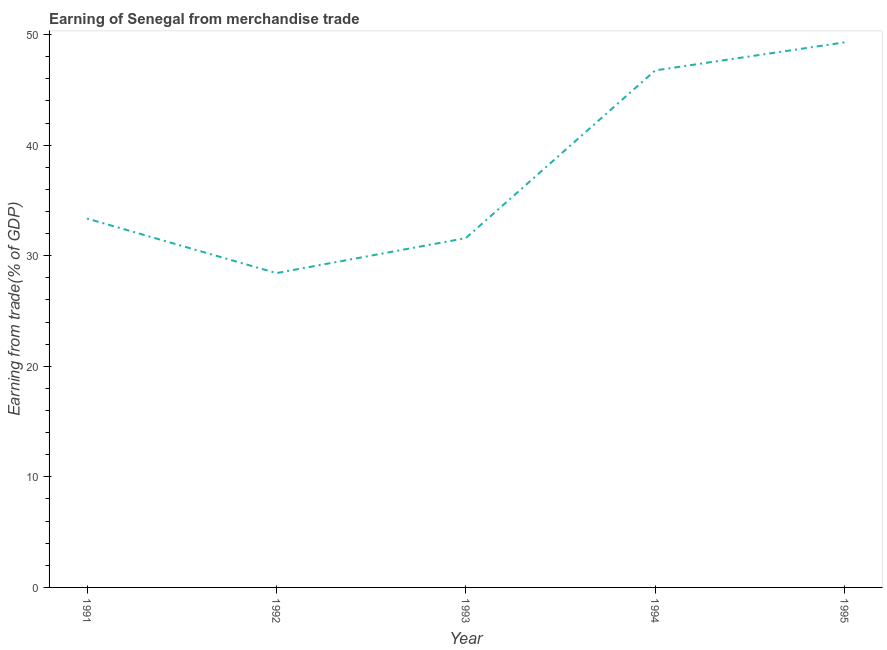What is the earning from merchandise trade in 1992?
Make the answer very short. 28.43. Across all years, what is the maximum earning from merchandise trade?
Your answer should be compact. 49.3. Across all years, what is the minimum earning from merchandise trade?
Make the answer very short. 28.43. What is the sum of the earning from merchandise trade?
Ensure brevity in your answer.  189.44. What is the difference between the earning from merchandise trade in 1991 and 1995?
Give a very brief answer. -15.93. What is the average earning from merchandise trade per year?
Keep it short and to the point. 37.89. What is the median earning from merchandise trade?
Offer a terse response. 33.36. Do a majority of the years between 1994 and 1991 (inclusive) have earning from merchandise trade greater than 12 %?
Give a very brief answer. Yes. What is the ratio of the earning from merchandise trade in 1994 to that in 1995?
Ensure brevity in your answer.  0.95. What is the difference between the highest and the second highest earning from merchandise trade?
Your response must be concise. 2.54. What is the difference between the highest and the lowest earning from merchandise trade?
Make the answer very short. 20.87. In how many years, is the earning from merchandise trade greater than the average earning from merchandise trade taken over all years?
Make the answer very short. 2. Does the earning from merchandise trade monotonically increase over the years?
Ensure brevity in your answer.  No. What is the title of the graph?
Provide a succinct answer. Earning of Senegal from merchandise trade. What is the label or title of the X-axis?
Ensure brevity in your answer.  Year. What is the label or title of the Y-axis?
Offer a very short reply. Earning from trade(% of GDP). What is the Earning from trade(% of GDP) of 1991?
Provide a short and direct response. 33.36. What is the Earning from trade(% of GDP) of 1992?
Give a very brief answer. 28.43. What is the Earning from trade(% of GDP) of 1993?
Make the answer very short. 31.59. What is the Earning from trade(% of GDP) of 1994?
Offer a very short reply. 46.76. What is the Earning from trade(% of GDP) in 1995?
Keep it short and to the point. 49.3. What is the difference between the Earning from trade(% of GDP) in 1991 and 1992?
Provide a short and direct response. 4.93. What is the difference between the Earning from trade(% of GDP) in 1991 and 1993?
Make the answer very short. 1.77. What is the difference between the Earning from trade(% of GDP) in 1991 and 1994?
Make the answer very short. -13.4. What is the difference between the Earning from trade(% of GDP) in 1991 and 1995?
Offer a terse response. -15.93. What is the difference between the Earning from trade(% of GDP) in 1992 and 1993?
Your answer should be very brief. -3.16. What is the difference between the Earning from trade(% of GDP) in 1992 and 1994?
Your response must be concise. -18.33. What is the difference between the Earning from trade(% of GDP) in 1992 and 1995?
Your response must be concise. -20.87. What is the difference between the Earning from trade(% of GDP) in 1993 and 1994?
Make the answer very short. -15.17. What is the difference between the Earning from trade(% of GDP) in 1993 and 1995?
Your response must be concise. -17.7. What is the difference between the Earning from trade(% of GDP) in 1994 and 1995?
Keep it short and to the point. -2.54. What is the ratio of the Earning from trade(% of GDP) in 1991 to that in 1992?
Ensure brevity in your answer.  1.17. What is the ratio of the Earning from trade(% of GDP) in 1991 to that in 1993?
Keep it short and to the point. 1.06. What is the ratio of the Earning from trade(% of GDP) in 1991 to that in 1994?
Keep it short and to the point. 0.71. What is the ratio of the Earning from trade(% of GDP) in 1991 to that in 1995?
Make the answer very short. 0.68. What is the ratio of the Earning from trade(% of GDP) in 1992 to that in 1994?
Your answer should be very brief. 0.61. What is the ratio of the Earning from trade(% of GDP) in 1992 to that in 1995?
Offer a very short reply. 0.58. What is the ratio of the Earning from trade(% of GDP) in 1993 to that in 1994?
Provide a succinct answer. 0.68. What is the ratio of the Earning from trade(% of GDP) in 1993 to that in 1995?
Your response must be concise. 0.64. What is the ratio of the Earning from trade(% of GDP) in 1994 to that in 1995?
Keep it short and to the point. 0.95. 